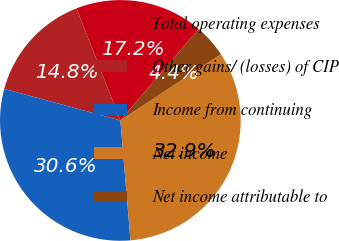<chart> <loc_0><loc_0><loc_500><loc_500><pie_chart><fcel>Total operating expenses<fcel>Other gains/ (losses) of CIP<fcel>Income from continuing<fcel>Net income<fcel>Net income attributable to<nl><fcel>17.21%<fcel>14.84%<fcel>30.56%<fcel>32.94%<fcel>4.45%<nl></chart> 